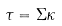<formula> <loc_0><loc_0><loc_500><loc_500>\tau = \Sigma \kappa</formula> 